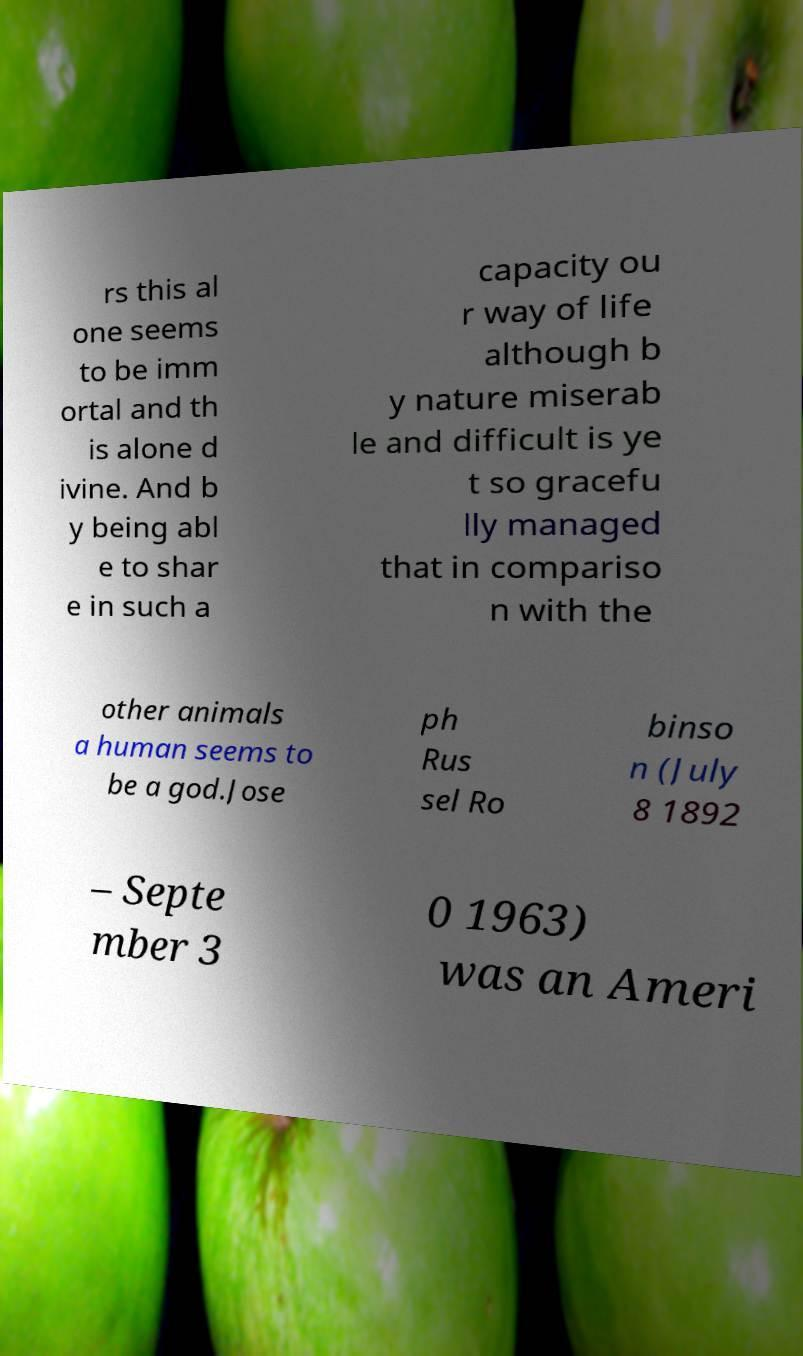I need the written content from this picture converted into text. Can you do that? rs this al one seems to be imm ortal and th is alone d ivine. And b y being abl e to shar e in such a capacity ou r way of life although b y nature miserab le and difficult is ye t so gracefu lly managed that in compariso n with the other animals a human seems to be a god.Jose ph Rus sel Ro binso n (July 8 1892 – Septe mber 3 0 1963) was an Ameri 